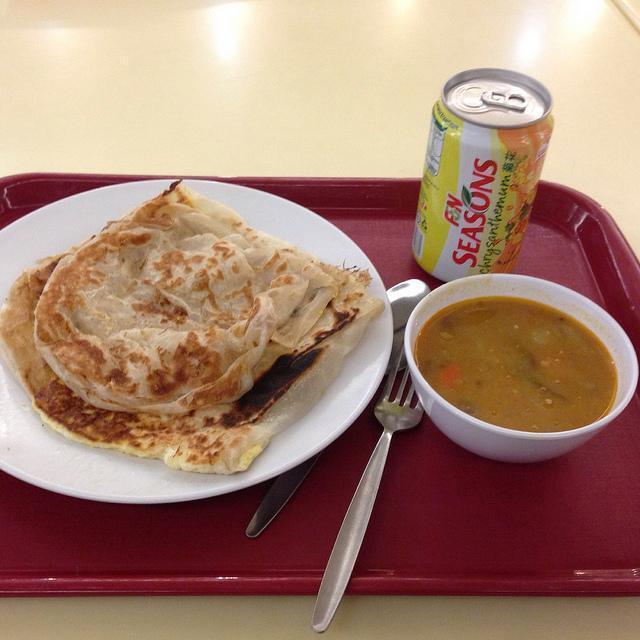Which item is probably the coldest?
Select the accurate response from the four choices given to answer the question.
Options: Can, plate, bowl, tray. Can. 